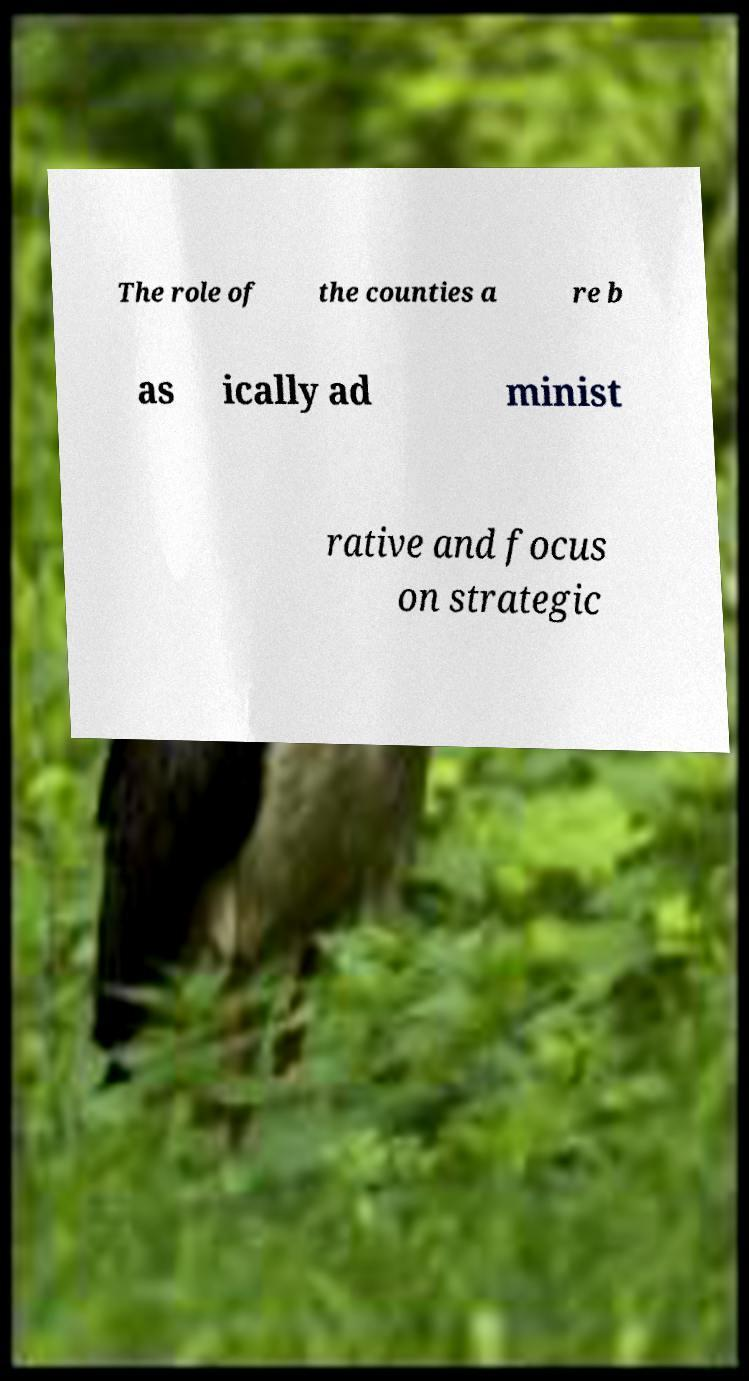Please read and relay the text visible in this image. What does it say? The role of the counties a re b as ically ad minist rative and focus on strategic 